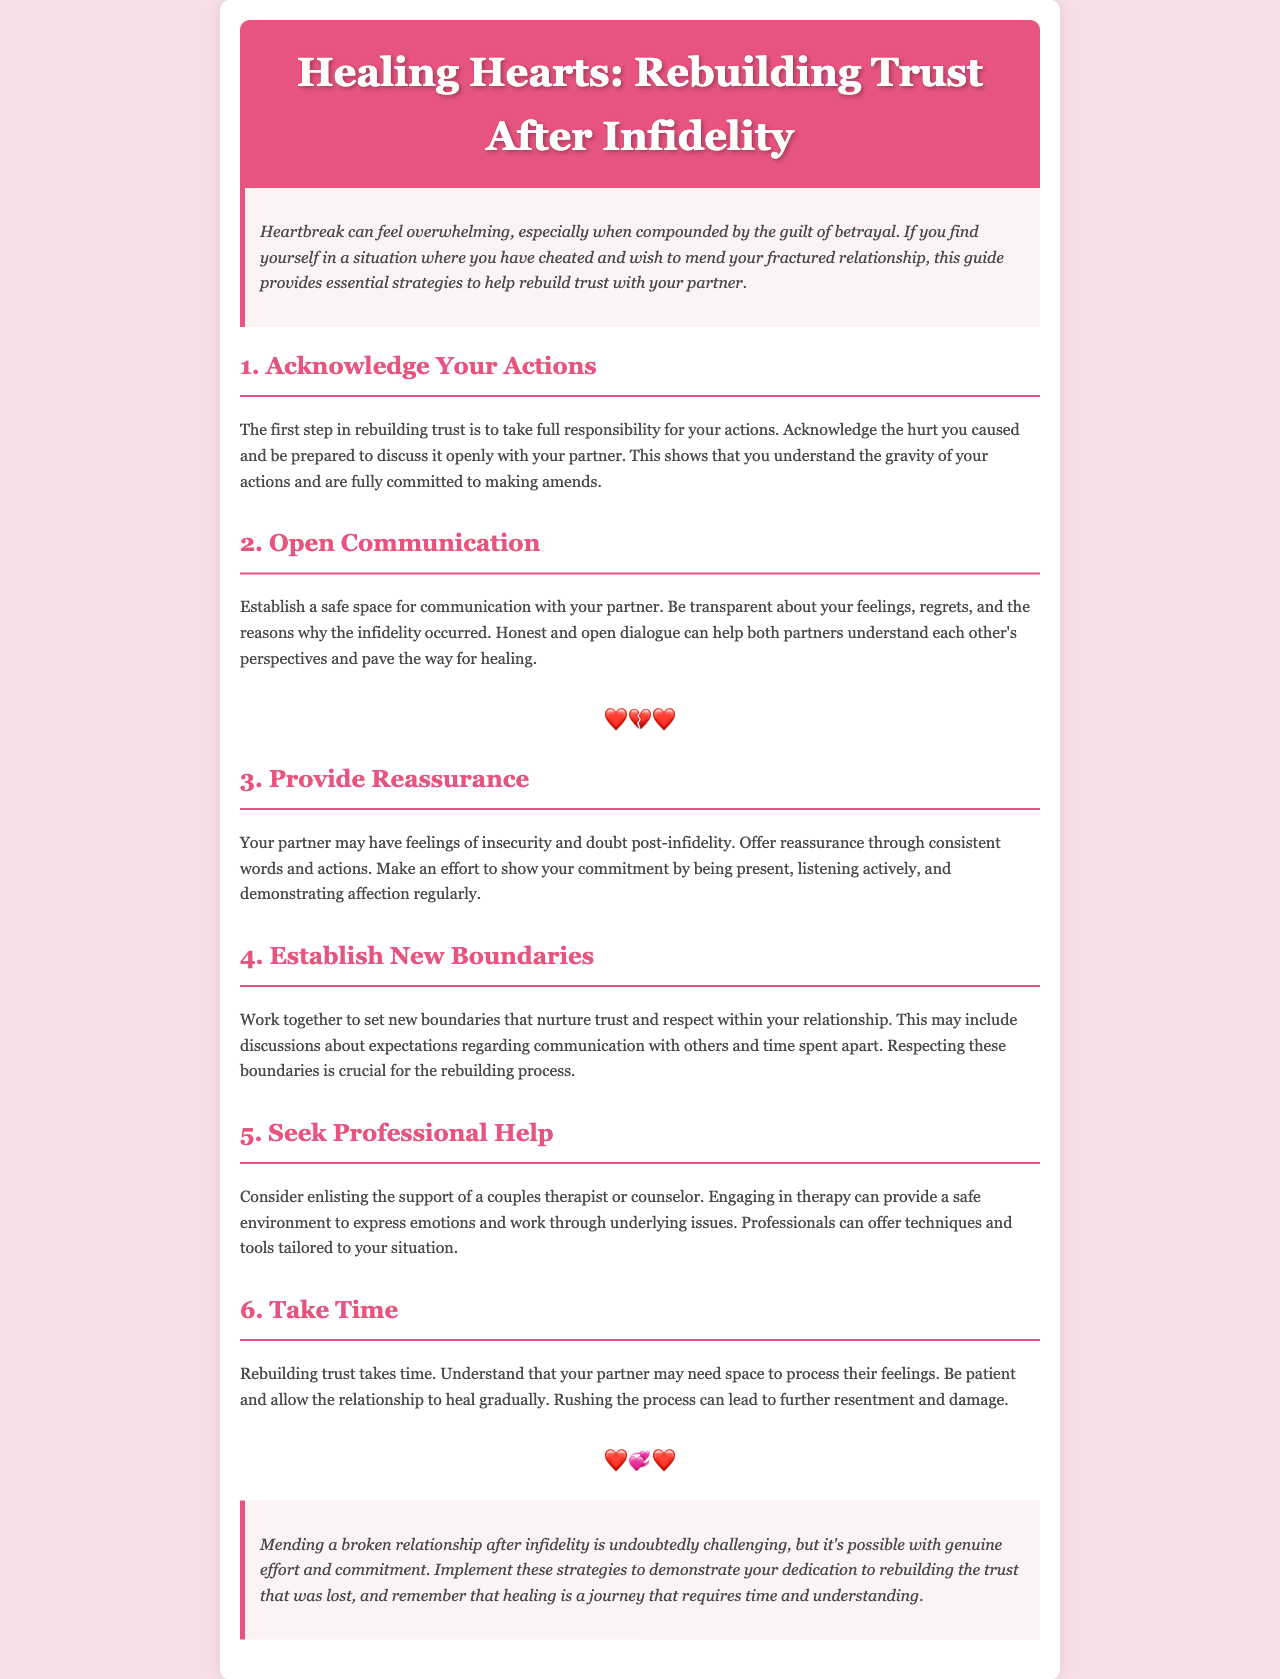What is the title of the newsletter? The title is found in the header section of the document, prominently displayed as the main heading.
Answer: Healing Hearts: Rebuilding Trust After Infidelity What is the first step in rebuilding trust? This information is listed in the first content section, outlining initial actions for healing.
Answer: Acknowledge Your Actions What color is the header background? The header background color is specified in the style section, denoting its appearance.
Answer: #e75480 How many strategies for rebuilding trust are listed? The document outlines a specific number of strategies in the content sections.
Answer: Six What is offered as a way to provide reassurance? This is explained in the third content section as a method of support for the partner.
Answer: Consistent words and actions What is suggested for couples who need additional support? The fifth content section recommends a particular professional assistance type to help couples.
Answer: Professional Help What does the introduction suggest heartbreak can feel like? The introduction describes the emotional impact of heartbreak, providing insight into the feelings involved.
Answer: Overwhelming What is emphasized as important when setting new boundaries? The fourth content section discusses the significance of respecting certain elements in the relationship.
Answer: Respecting these boundaries What type of environment does engaging in therapy provide? This information can be found in the fifth strategy, discussing the role of therapy in rebuilding trust.
Answer: Safe environment 